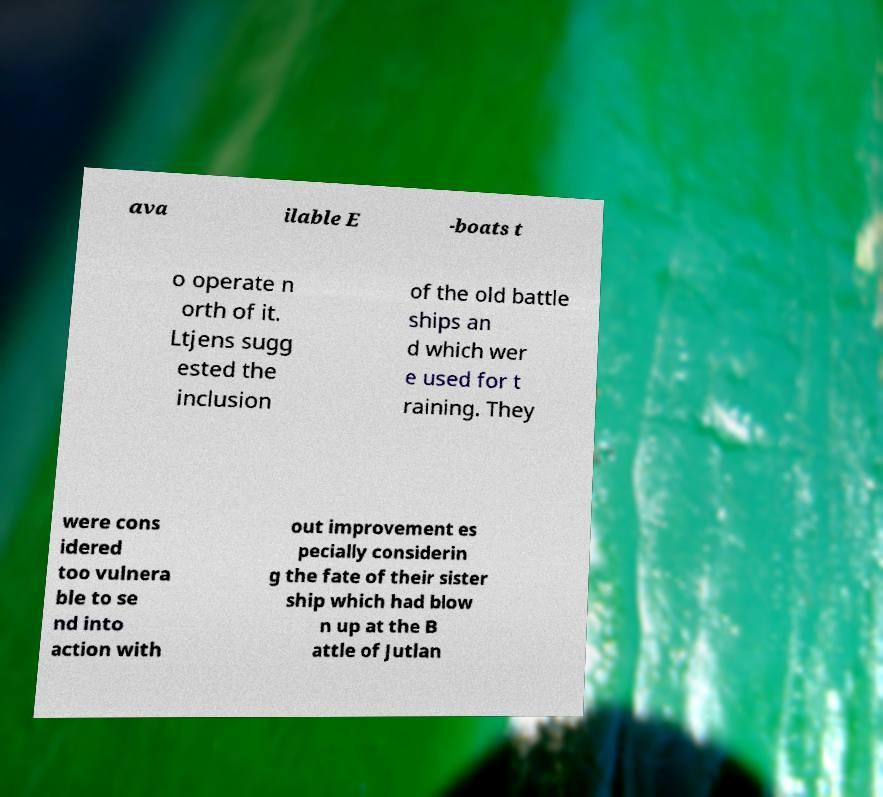What messages or text are displayed in this image? I need them in a readable, typed format. ava ilable E -boats t o operate n orth of it. Ltjens sugg ested the inclusion of the old battle ships an d which wer e used for t raining. They were cons idered too vulnera ble to se nd into action with out improvement es pecially considerin g the fate of their sister ship which had blow n up at the B attle of Jutlan 